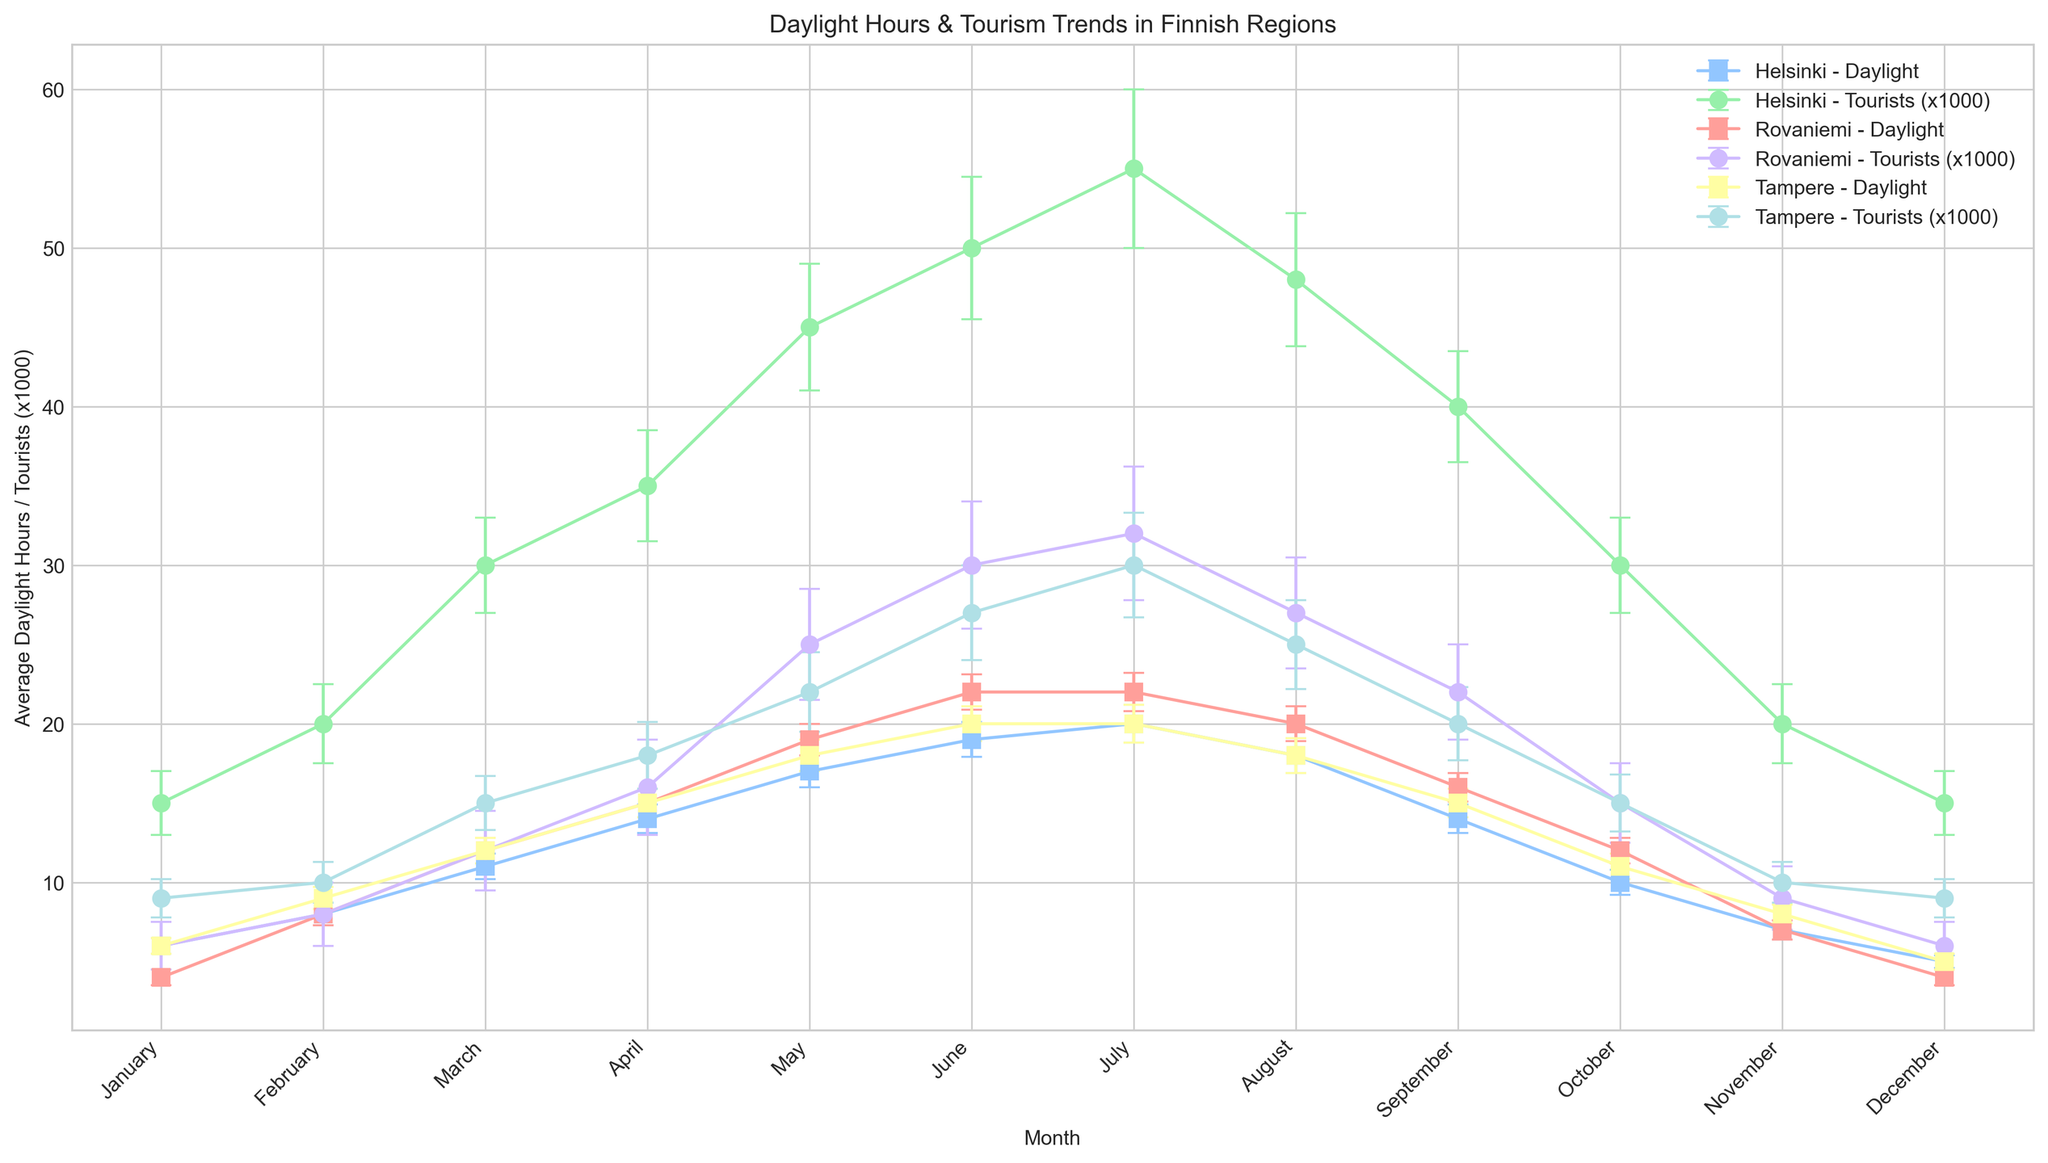What's the region experiencing the largest increase in average daylight hours from January to July? To determine which region has the largest increase in daylight hours from January to July, we must subtract the January values from the July values for each region. For Helsinki, the increase is 20 - 6 = 14 hours. For Rovaniemi, it's 22 - 4 = 18 hours. For Tampere, it's 20 - 6 = 14 hours. Thus, Rovaniemi experiences the largest increase.
Answer: Rovaniemi Which region has the highest number of tourists in June? To find the region with the highest number of tourists in June, we must compare the tourist values for June across all regions. For Helsinki, there are 50,000 tourists; for Rovaniemi, there are 30,000 tourists; and for Tampere, there are 27,000 tourists. Helsinki has the highest number of tourists in June.
Answer: Helsinki In which month does Helsinki have the smallest average number of daylight hours? By examining the bars representing daylight hours for Helsinki, we see that December has the smallest average number of daylight hours at 5 hours.
Answer: December Compare the average daylight hours in August for Helsinki and Rovaniemi. Which region has more sunlight? In August, Helsinki has 18 average daylight hours, while Rovaniemi has 20 average daylight hours. Thus, Rovaniemi has more sunlight in August.
Answer: Rovaniemi What is the average number of tourists in Tampere during the months with the highest and lowest average daylight hours? Finding the months with the highest and lowest daylight hours for Tampere, we see July (20 hours) and December (5 hours). In July, there are 30,000 tourists; in December, there are 9,000 tourists. The average is (30,000 + 9,000) / 2, which equals 19,500 tourists.
Answer: 19,500 What's the difference in the average number of daylight hours between April and November in Rovaniemi? In Rovaniemi, April has 15 average daylight hours, and November has 7 average daylight hours. The difference is 15 - 7, which equals 8 hours.
Answer: 8 hours Which region shows the greatest fluctuation in the number of tourists between January and December? To find the greatest fluctuation, we need to calculate the difference between January and December tourist numbers for each region. Helsinki: 15,000 - 15,000 = 0; Rovaniemi: 6,000 - 6,000 = 0; Tampere: 9,000 - 9,000 = 0. All regions have the same fluctuation of 0.
Answer: None In which month do Tampere and Helsinki both share the same average daylight hours? To identify this, look for equal values in the daylight hours of Tampere and Helsinki. Both regions have exactly 6 average daylight hours in January.
Answer: January During which month does Rovaniemi have the minimum number of tourists? Observing the tourist data for Rovaniemi, the minimum occurs in January and December with 6,000 tourists.
Answer: January and December What's the difference between the maximum and minimum number of tourists in Helsinki throughout the year? To find the difference, subtract the minimum tourist value from the maximum. In Helsinki, the max is 55,000 (July), and the min is 15,000 (January and December), so the difference is 55,000 - 15,000, which equals 40,000 tourists.
Answer: 40,000 